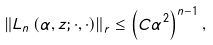Convert formula to latex. <formula><loc_0><loc_0><loc_500><loc_500>\left \| L _ { n } \left ( \alpha , z ; \cdot , \cdot \right ) \right \| _ { r } \leq \left ( C \alpha ^ { 2 } \right ) ^ { n - 1 } ,</formula> 